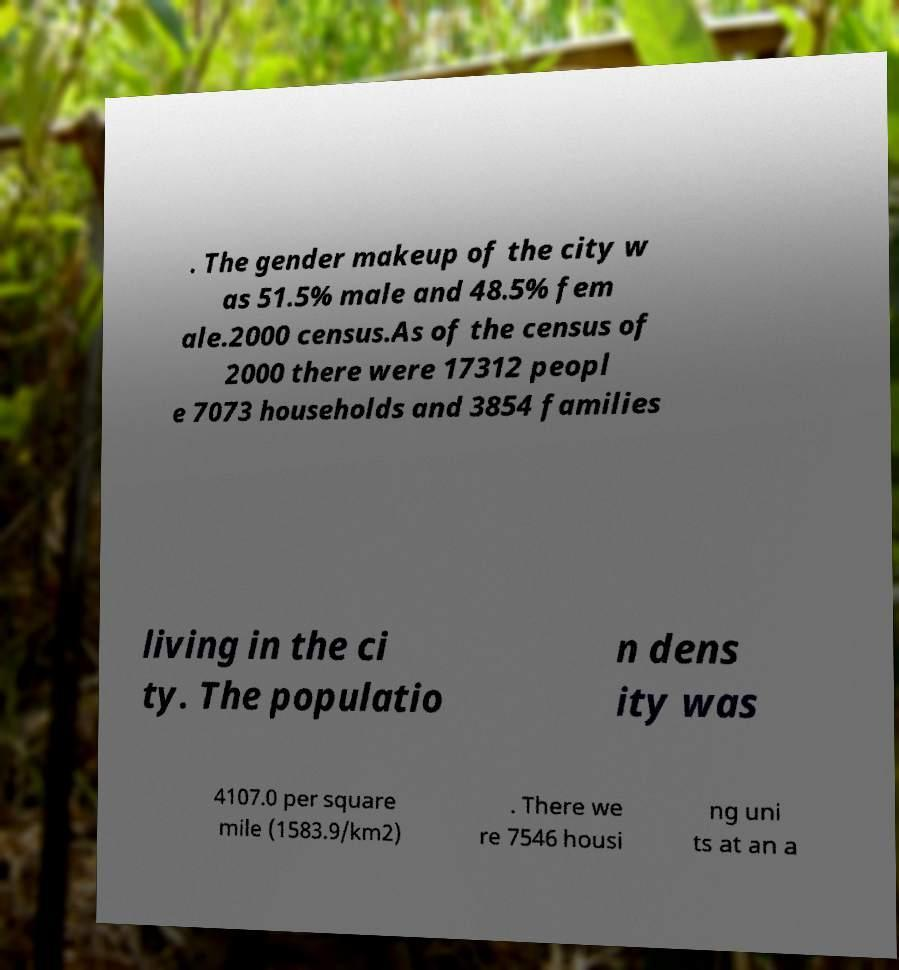I need the written content from this picture converted into text. Can you do that? . The gender makeup of the city w as 51.5% male and 48.5% fem ale.2000 census.As of the census of 2000 there were 17312 peopl e 7073 households and 3854 families living in the ci ty. The populatio n dens ity was 4107.0 per square mile (1583.9/km2) . There we re 7546 housi ng uni ts at an a 